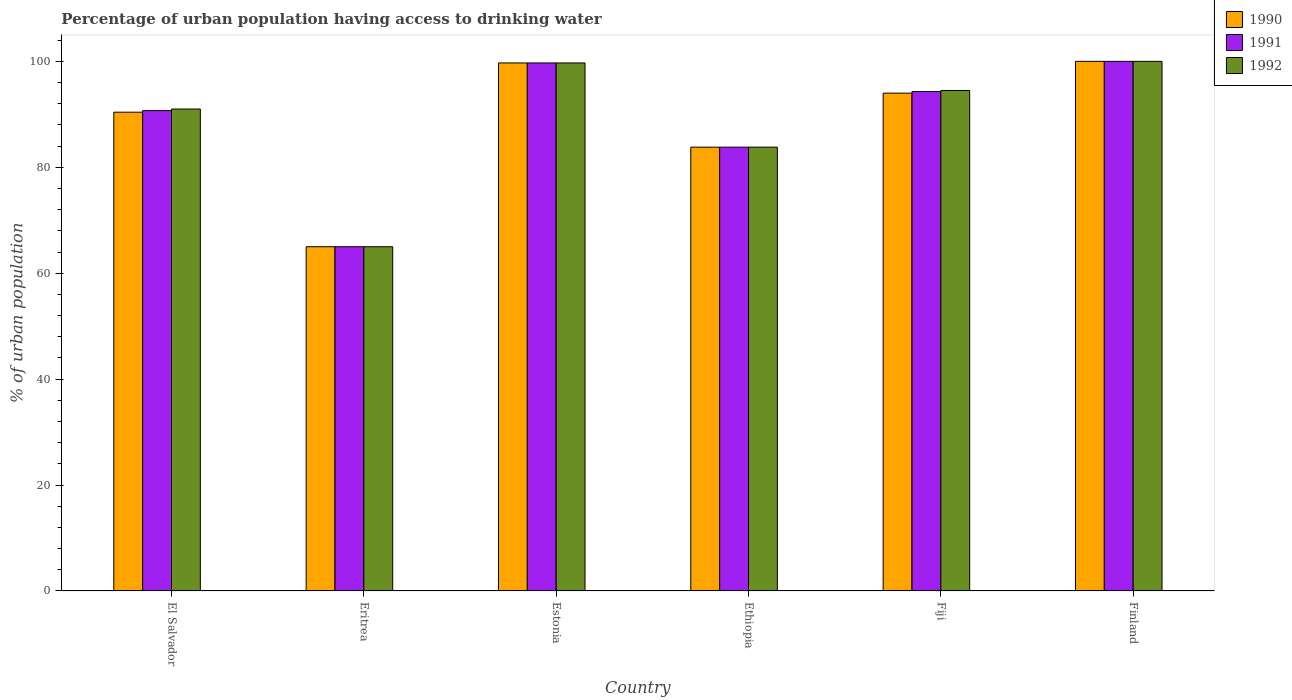How many groups of bars are there?
Ensure brevity in your answer.  6. Are the number of bars per tick equal to the number of legend labels?
Make the answer very short. Yes. Are the number of bars on each tick of the X-axis equal?
Give a very brief answer. Yes. How many bars are there on the 4th tick from the left?
Offer a very short reply. 3. How many bars are there on the 2nd tick from the right?
Ensure brevity in your answer.  3. What is the label of the 6th group of bars from the left?
Give a very brief answer. Finland. In which country was the percentage of urban population having access to drinking water in 1990 minimum?
Make the answer very short. Eritrea. What is the total percentage of urban population having access to drinking water in 1991 in the graph?
Ensure brevity in your answer.  533.5. What is the difference between the percentage of urban population having access to drinking water in 1992 in El Salvador and that in Estonia?
Give a very brief answer. -8.7. What is the difference between the percentage of urban population having access to drinking water in 1991 in El Salvador and the percentage of urban population having access to drinking water in 1992 in Ethiopia?
Your answer should be compact. 6.9. What is the average percentage of urban population having access to drinking water in 1990 per country?
Keep it short and to the point. 88.82. What is the difference between the percentage of urban population having access to drinking water of/in 1991 and percentage of urban population having access to drinking water of/in 1990 in El Salvador?
Offer a terse response. 0.3. What is the ratio of the percentage of urban population having access to drinking water in 1991 in Eritrea to that in Estonia?
Give a very brief answer. 0.65. Is the difference between the percentage of urban population having access to drinking water in 1991 in Eritrea and Finland greater than the difference between the percentage of urban population having access to drinking water in 1990 in Eritrea and Finland?
Give a very brief answer. No. What is the difference between the highest and the second highest percentage of urban population having access to drinking water in 1992?
Keep it short and to the point. -0.3. What is the difference between the highest and the lowest percentage of urban population having access to drinking water in 1990?
Provide a succinct answer. 35. Is the sum of the percentage of urban population having access to drinking water in 1990 in El Salvador and Eritrea greater than the maximum percentage of urban population having access to drinking water in 1992 across all countries?
Your response must be concise. Yes. Is it the case that in every country, the sum of the percentage of urban population having access to drinking water in 1992 and percentage of urban population having access to drinking water in 1990 is greater than the percentage of urban population having access to drinking water in 1991?
Your response must be concise. Yes. How many bars are there?
Your response must be concise. 18. Are all the bars in the graph horizontal?
Offer a very short reply. No. How many countries are there in the graph?
Make the answer very short. 6. Are the values on the major ticks of Y-axis written in scientific E-notation?
Your answer should be very brief. No. Where does the legend appear in the graph?
Your response must be concise. Top right. How many legend labels are there?
Your response must be concise. 3. How are the legend labels stacked?
Provide a succinct answer. Vertical. What is the title of the graph?
Ensure brevity in your answer.  Percentage of urban population having access to drinking water. What is the label or title of the Y-axis?
Offer a terse response. % of urban population. What is the % of urban population in 1990 in El Salvador?
Ensure brevity in your answer.  90.4. What is the % of urban population of 1991 in El Salvador?
Your answer should be very brief. 90.7. What is the % of urban population of 1992 in El Salvador?
Offer a very short reply. 91. What is the % of urban population of 1992 in Eritrea?
Offer a very short reply. 65. What is the % of urban population in 1990 in Estonia?
Offer a very short reply. 99.7. What is the % of urban population of 1991 in Estonia?
Your answer should be compact. 99.7. What is the % of urban population in 1992 in Estonia?
Offer a terse response. 99.7. What is the % of urban population of 1990 in Ethiopia?
Offer a terse response. 83.8. What is the % of urban population of 1991 in Ethiopia?
Keep it short and to the point. 83.8. What is the % of urban population in 1992 in Ethiopia?
Ensure brevity in your answer.  83.8. What is the % of urban population in 1990 in Fiji?
Your answer should be compact. 94. What is the % of urban population in 1991 in Fiji?
Keep it short and to the point. 94.3. What is the % of urban population in 1992 in Fiji?
Provide a short and direct response. 94.5. What is the % of urban population in 1990 in Finland?
Your answer should be compact. 100. Across all countries, what is the maximum % of urban population in 1990?
Make the answer very short. 100. Across all countries, what is the minimum % of urban population of 1990?
Offer a very short reply. 65. What is the total % of urban population in 1990 in the graph?
Your answer should be compact. 532.9. What is the total % of urban population of 1991 in the graph?
Your answer should be compact. 533.5. What is the total % of urban population of 1992 in the graph?
Provide a short and direct response. 534. What is the difference between the % of urban population of 1990 in El Salvador and that in Eritrea?
Offer a terse response. 25.4. What is the difference between the % of urban population in 1991 in El Salvador and that in Eritrea?
Your response must be concise. 25.7. What is the difference between the % of urban population of 1992 in El Salvador and that in Eritrea?
Make the answer very short. 26. What is the difference between the % of urban population of 1990 in El Salvador and that in Estonia?
Ensure brevity in your answer.  -9.3. What is the difference between the % of urban population of 1990 in El Salvador and that in Ethiopia?
Give a very brief answer. 6.6. What is the difference between the % of urban population in 1991 in El Salvador and that in Fiji?
Keep it short and to the point. -3.6. What is the difference between the % of urban population in 1990 in El Salvador and that in Finland?
Provide a succinct answer. -9.6. What is the difference between the % of urban population of 1992 in El Salvador and that in Finland?
Ensure brevity in your answer.  -9. What is the difference between the % of urban population of 1990 in Eritrea and that in Estonia?
Give a very brief answer. -34.7. What is the difference between the % of urban population of 1991 in Eritrea and that in Estonia?
Offer a very short reply. -34.7. What is the difference between the % of urban population of 1992 in Eritrea and that in Estonia?
Make the answer very short. -34.7. What is the difference between the % of urban population of 1990 in Eritrea and that in Ethiopia?
Offer a terse response. -18.8. What is the difference between the % of urban population of 1991 in Eritrea and that in Ethiopia?
Provide a succinct answer. -18.8. What is the difference between the % of urban population of 1992 in Eritrea and that in Ethiopia?
Offer a very short reply. -18.8. What is the difference between the % of urban population of 1990 in Eritrea and that in Fiji?
Make the answer very short. -29. What is the difference between the % of urban population of 1991 in Eritrea and that in Fiji?
Offer a very short reply. -29.3. What is the difference between the % of urban population in 1992 in Eritrea and that in Fiji?
Ensure brevity in your answer.  -29.5. What is the difference between the % of urban population of 1990 in Eritrea and that in Finland?
Provide a succinct answer. -35. What is the difference between the % of urban population of 1991 in Eritrea and that in Finland?
Offer a very short reply. -35. What is the difference between the % of urban population of 1992 in Eritrea and that in Finland?
Give a very brief answer. -35. What is the difference between the % of urban population in 1990 in Estonia and that in Ethiopia?
Offer a terse response. 15.9. What is the difference between the % of urban population in 1991 in Estonia and that in Ethiopia?
Offer a very short reply. 15.9. What is the difference between the % of urban population in 1990 in Estonia and that in Finland?
Provide a succinct answer. -0.3. What is the difference between the % of urban population in 1992 in Estonia and that in Finland?
Offer a terse response. -0.3. What is the difference between the % of urban population of 1990 in Ethiopia and that in Fiji?
Your answer should be very brief. -10.2. What is the difference between the % of urban population of 1990 in Ethiopia and that in Finland?
Your answer should be very brief. -16.2. What is the difference between the % of urban population of 1991 in Ethiopia and that in Finland?
Offer a very short reply. -16.2. What is the difference between the % of urban population of 1992 in Ethiopia and that in Finland?
Provide a succinct answer. -16.2. What is the difference between the % of urban population of 1990 in Fiji and that in Finland?
Your answer should be compact. -6. What is the difference between the % of urban population in 1992 in Fiji and that in Finland?
Offer a terse response. -5.5. What is the difference between the % of urban population in 1990 in El Salvador and the % of urban population in 1991 in Eritrea?
Offer a terse response. 25.4. What is the difference between the % of urban population in 1990 in El Salvador and the % of urban population in 1992 in Eritrea?
Ensure brevity in your answer.  25.4. What is the difference between the % of urban population in 1991 in El Salvador and the % of urban population in 1992 in Eritrea?
Your response must be concise. 25.7. What is the difference between the % of urban population of 1991 in El Salvador and the % of urban population of 1992 in Estonia?
Provide a short and direct response. -9. What is the difference between the % of urban population in 1990 in El Salvador and the % of urban population in 1991 in Ethiopia?
Ensure brevity in your answer.  6.6. What is the difference between the % of urban population in 1991 in El Salvador and the % of urban population in 1992 in Ethiopia?
Provide a succinct answer. 6.9. What is the difference between the % of urban population in 1990 in El Salvador and the % of urban population in 1991 in Fiji?
Provide a succinct answer. -3.9. What is the difference between the % of urban population of 1990 in El Salvador and the % of urban population of 1992 in Fiji?
Your answer should be very brief. -4.1. What is the difference between the % of urban population of 1990 in El Salvador and the % of urban population of 1991 in Finland?
Offer a terse response. -9.6. What is the difference between the % of urban population in 1991 in El Salvador and the % of urban population in 1992 in Finland?
Offer a terse response. -9.3. What is the difference between the % of urban population in 1990 in Eritrea and the % of urban population in 1991 in Estonia?
Ensure brevity in your answer.  -34.7. What is the difference between the % of urban population of 1990 in Eritrea and the % of urban population of 1992 in Estonia?
Make the answer very short. -34.7. What is the difference between the % of urban population in 1991 in Eritrea and the % of urban population in 1992 in Estonia?
Provide a short and direct response. -34.7. What is the difference between the % of urban population of 1990 in Eritrea and the % of urban population of 1991 in Ethiopia?
Offer a terse response. -18.8. What is the difference between the % of urban population of 1990 in Eritrea and the % of urban population of 1992 in Ethiopia?
Offer a terse response. -18.8. What is the difference between the % of urban population in 1991 in Eritrea and the % of urban population in 1992 in Ethiopia?
Make the answer very short. -18.8. What is the difference between the % of urban population of 1990 in Eritrea and the % of urban population of 1991 in Fiji?
Keep it short and to the point. -29.3. What is the difference between the % of urban population of 1990 in Eritrea and the % of urban population of 1992 in Fiji?
Your answer should be compact. -29.5. What is the difference between the % of urban population in 1991 in Eritrea and the % of urban population in 1992 in Fiji?
Your response must be concise. -29.5. What is the difference between the % of urban population in 1990 in Eritrea and the % of urban population in 1991 in Finland?
Offer a terse response. -35. What is the difference between the % of urban population in 1990 in Eritrea and the % of urban population in 1992 in Finland?
Offer a terse response. -35. What is the difference between the % of urban population of 1991 in Eritrea and the % of urban population of 1992 in Finland?
Make the answer very short. -35. What is the difference between the % of urban population in 1990 in Estonia and the % of urban population in 1991 in Fiji?
Give a very brief answer. 5.4. What is the difference between the % of urban population in 1991 in Estonia and the % of urban population in 1992 in Fiji?
Offer a very short reply. 5.2. What is the difference between the % of urban population in 1990 in Estonia and the % of urban population in 1991 in Finland?
Your response must be concise. -0.3. What is the difference between the % of urban population of 1991 in Estonia and the % of urban population of 1992 in Finland?
Make the answer very short. -0.3. What is the difference between the % of urban population of 1990 in Ethiopia and the % of urban population of 1991 in Fiji?
Provide a short and direct response. -10.5. What is the difference between the % of urban population in 1990 in Ethiopia and the % of urban population in 1991 in Finland?
Give a very brief answer. -16.2. What is the difference between the % of urban population of 1990 in Ethiopia and the % of urban population of 1992 in Finland?
Provide a short and direct response. -16.2. What is the difference between the % of urban population in 1991 in Ethiopia and the % of urban population in 1992 in Finland?
Ensure brevity in your answer.  -16.2. What is the average % of urban population of 1990 per country?
Your answer should be compact. 88.82. What is the average % of urban population in 1991 per country?
Your response must be concise. 88.92. What is the average % of urban population in 1992 per country?
Your answer should be compact. 89. What is the difference between the % of urban population in 1990 and % of urban population in 1991 in El Salvador?
Your answer should be very brief. -0.3. What is the difference between the % of urban population of 1990 and % of urban population of 1992 in El Salvador?
Offer a very short reply. -0.6. What is the difference between the % of urban population in 1991 and % of urban population in 1992 in El Salvador?
Keep it short and to the point. -0.3. What is the difference between the % of urban population of 1990 and % of urban population of 1992 in Eritrea?
Your answer should be compact. 0. What is the difference between the % of urban population in 1991 and % of urban population in 1992 in Eritrea?
Your response must be concise. 0. What is the difference between the % of urban population of 1990 and % of urban population of 1991 in Ethiopia?
Give a very brief answer. 0. What is the difference between the % of urban population of 1991 and % of urban population of 1992 in Ethiopia?
Your response must be concise. 0. What is the difference between the % of urban population of 1991 and % of urban population of 1992 in Fiji?
Your answer should be very brief. -0.2. What is the difference between the % of urban population in 1990 and % of urban population in 1991 in Finland?
Keep it short and to the point. 0. What is the ratio of the % of urban population in 1990 in El Salvador to that in Eritrea?
Your answer should be very brief. 1.39. What is the ratio of the % of urban population in 1991 in El Salvador to that in Eritrea?
Provide a short and direct response. 1.4. What is the ratio of the % of urban population of 1992 in El Salvador to that in Eritrea?
Give a very brief answer. 1.4. What is the ratio of the % of urban population of 1990 in El Salvador to that in Estonia?
Your answer should be very brief. 0.91. What is the ratio of the % of urban population of 1991 in El Salvador to that in Estonia?
Keep it short and to the point. 0.91. What is the ratio of the % of urban population of 1992 in El Salvador to that in Estonia?
Offer a terse response. 0.91. What is the ratio of the % of urban population in 1990 in El Salvador to that in Ethiopia?
Provide a short and direct response. 1.08. What is the ratio of the % of urban population in 1991 in El Salvador to that in Ethiopia?
Your answer should be very brief. 1.08. What is the ratio of the % of urban population in 1992 in El Salvador to that in Ethiopia?
Provide a succinct answer. 1.09. What is the ratio of the % of urban population of 1990 in El Salvador to that in Fiji?
Offer a very short reply. 0.96. What is the ratio of the % of urban population in 1991 in El Salvador to that in Fiji?
Offer a terse response. 0.96. What is the ratio of the % of urban population in 1990 in El Salvador to that in Finland?
Ensure brevity in your answer.  0.9. What is the ratio of the % of urban population in 1991 in El Salvador to that in Finland?
Provide a succinct answer. 0.91. What is the ratio of the % of urban population of 1992 in El Salvador to that in Finland?
Offer a terse response. 0.91. What is the ratio of the % of urban population of 1990 in Eritrea to that in Estonia?
Provide a succinct answer. 0.65. What is the ratio of the % of urban population of 1991 in Eritrea to that in Estonia?
Keep it short and to the point. 0.65. What is the ratio of the % of urban population in 1992 in Eritrea to that in Estonia?
Your response must be concise. 0.65. What is the ratio of the % of urban population in 1990 in Eritrea to that in Ethiopia?
Your answer should be compact. 0.78. What is the ratio of the % of urban population in 1991 in Eritrea to that in Ethiopia?
Make the answer very short. 0.78. What is the ratio of the % of urban population in 1992 in Eritrea to that in Ethiopia?
Give a very brief answer. 0.78. What is the ratio of the % of urban population in 1990 in Eritrea to that in Fiji?
Keep it short and to the point. 0.69. What is the ratio of the % of urban population in 1991 in Eritrea to that in Fiji?
Offer a very short reply. 0.69. What is the ratio of the % of urban population of 1992 in Eritrea to that in Fiji?
Offer a terse response. 0.69. What is the ratio of the % of urban population of 1990 in Eritrea to that in Finland?
Provide a succinct answer. 0.65. What is the ratio of the % of urban population in 1991 in Eritrea to that in Finland?
Provide a short and direct response. 0.65. What is the ratio of the % of urban population in 1992 in Eritrea to that in Finland?
Your answer should be very brief. 0.65. What is the ratio of the % of urban population of 1990 in Estonia to that in Ethiopia?
Make the answer very short. 1.19. What is the ratio of the % of urban population of 1991 in Estonia to that in Ethiopia?
Provide a short and direct response. 1.19. What is the ratio of the % of urban population of 1992 in Estonia to that in Ethiopia?
Your answer should be very brief. 1.19. What is the ratio of the % of urban population of 1990 in Estonia to that in Fiji?
Your answer should be compact. 1.06. What is the ratio of the % of urban population in 1991 in Estonia to that in Fiji?
Provide a short and direct response. 1.06. What is the ratio of the % of urban population of 1992 in Estonia to that in Fiji?
Offer a very short reply. 1.05. What is the ratio of the % of urban population in 1990 in Estonia to that in Finland?
Make the answer very short. 1. What is the ratio of the % of urban population in 1991 in Estonia to that in Finland?
Offer a terse response. 1. What is the ratio of the % of urban population in 1992 in Estonia to that in Finland?
Offer a terse response. 1. What is the ratio of the % of urban population of 1990 in Ethiopia to that in Fiji?
Your answer should be very brief. 0.89. What is the ratio of the % of urban population in 1991 in Ethiopia to that in Fiji?
Keep it short and to the point. 0.89. What is the ratio of the % of urban population of 1992 in Ethiopia to that in Fiji?
Keep it short and to the point. 0.89. What is the ratio of the % of urban population of 1990 in Ethiopia to that in Finland?
Your answer should be compact. 0.84. What is the ratio of the % of urban population in 1991 in Ethiopia to that in Finland?
Your response must be concise. 0.84. What is the ratio of the % of urban population of 1992 in Ethiopia to that in Finland?
Ensure brevity in your answer.  0.84. What is the ratio of the % of urban population of 1990 in Fiji to that in Finland?
Offer a very short reply. 0.94. What is the ratio of the % of urban population of 1991 in Fiji to that in Finland?
Your response must be concise. 0.94. What is the ratio of the % of urban population of 1992 in Fiji to that in Finland?
Provide a short and direct response. 0.94. 